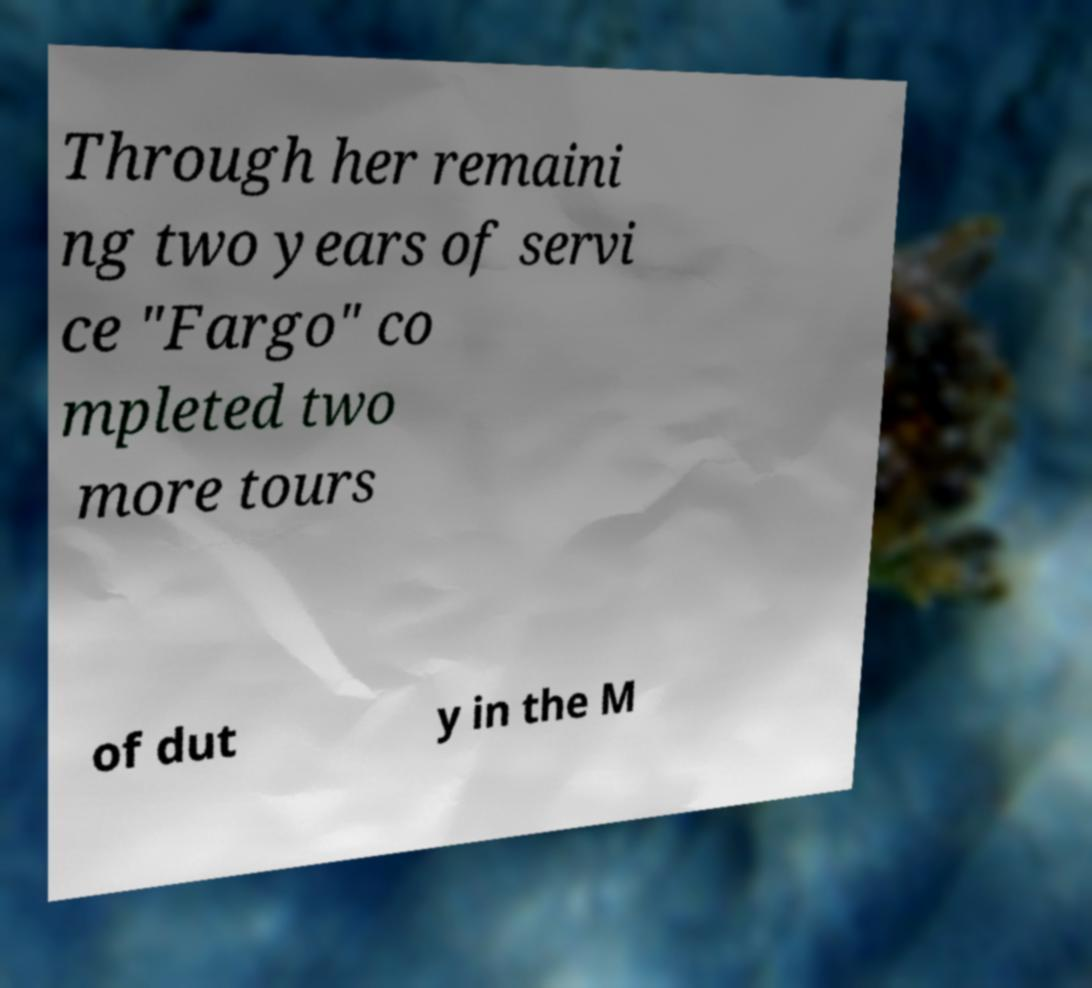Could you extract and type out the text from this image? Through her remaini ng two years of servi ce "Fargo" co mpleted two more tours of dut y in the M 